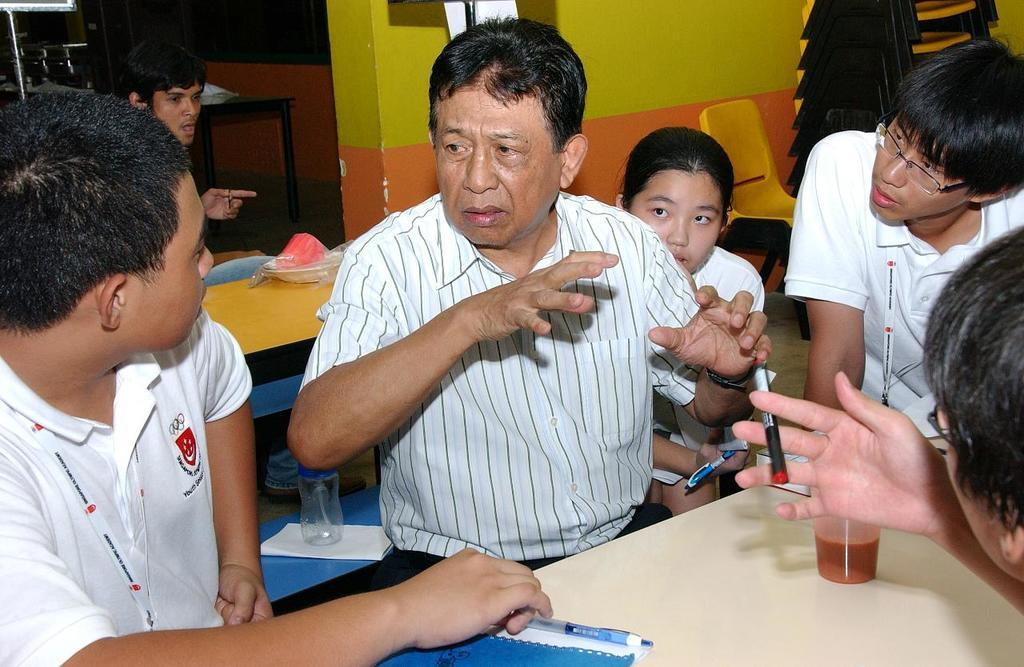How many people can be seen in the image? There are people in the image, but the exact number is not specified. What are two of the people holding? Two of the people are holding pens. What type of furniture is present in the image? There are tables and chairs in the image. What items can be found on the tables? Papers, pens, a book, and a glass bottle are present on the tables. What is visible in the background of the image? There is a wall visible in the image. Where are the kittens playing in the image? There are no kittens present in the image. What type of toothbrush is on the table in the image? There is no toothbrush present in the image. 